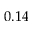<formula> <loc_0><loc_0><loc_500><loc_500>0 . 1 4</formula> 